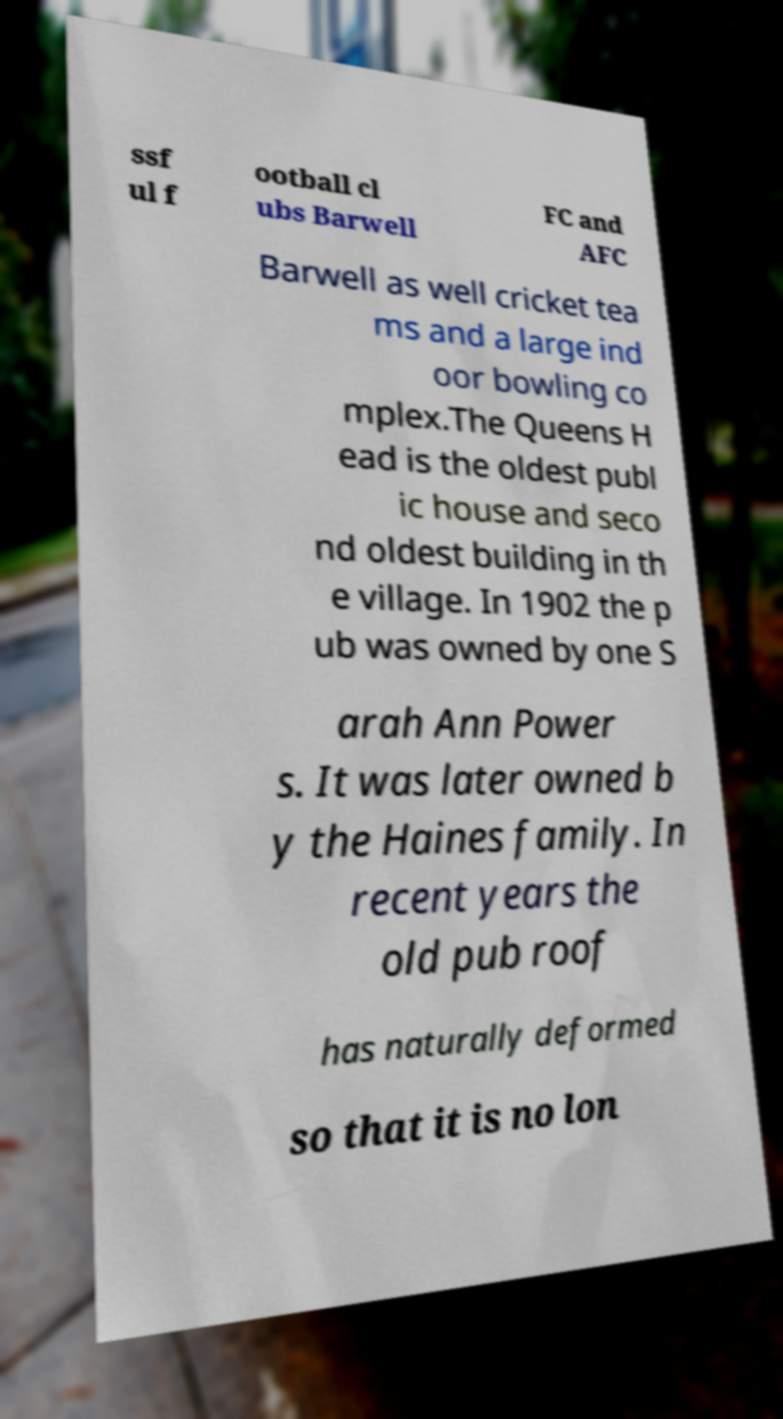What messages or text are displayed in this image? I need them in a readable, typed format. ssf ul f ootball cl ubs Barwell FC and AFC Barwell as well cricket tea ms and a large ind oor bowling co mplex.The Queens H ead is the oldest publ ic house and seco nd oldest building in th e village. In 1902 the p ub was owned by one S arah Ann Power s. It was later owned b y the Haines family. In recent years the old pub roof has naturally deformed so that it is no lon 